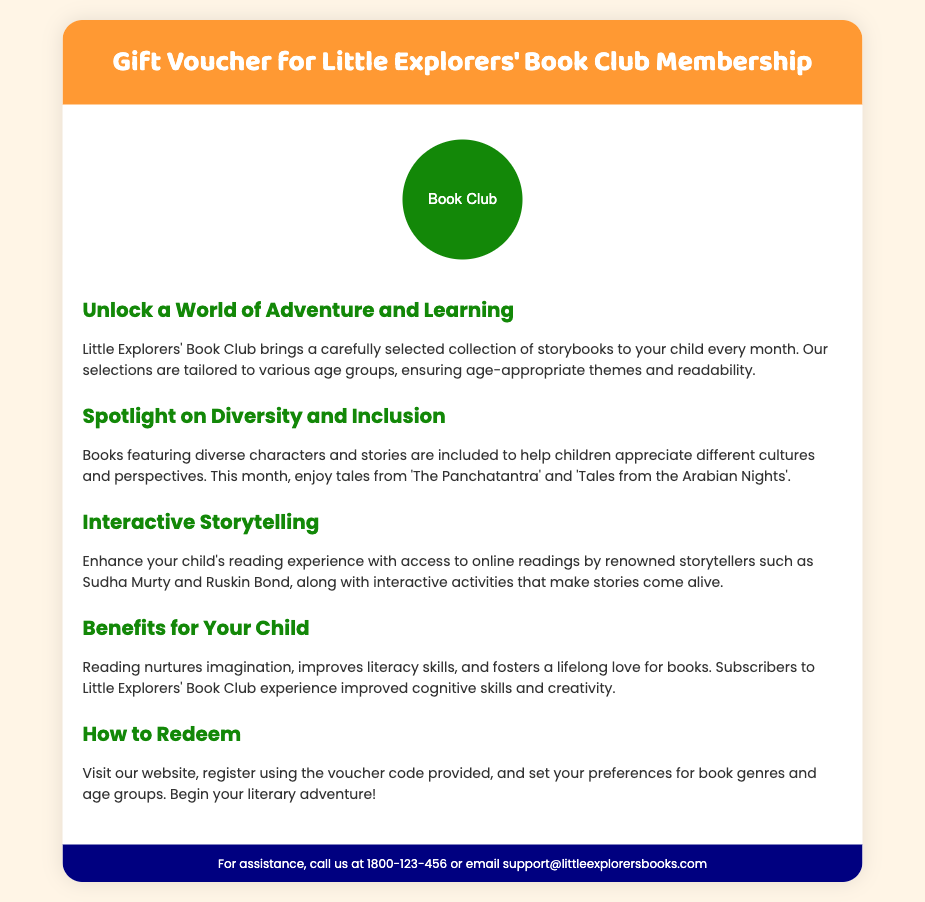What is the name of the book club? The document explicitly mentions the book club's name as "Little Explorers' Book Club."
Answer: Little Explorers' Book Club What is the color of the header? The header section of the voucher is primarily colored in orange, as indicated by the style code provided.
Answer: Orange Who are some of the renowned storytellers mentioned? The document lists Sudha Murty and Ruskin Bond as renowned storytellers featured in the online readings.
Answer: Sudha Murty and Ruskin Bond What type of books are included in the book club? The club offers a collection of "storybooks," which are tailored to various age groups and themes.
Answer: Storybooks How can a voucher be redeemed? The document explains that you need to visit the website, register with the voucher code, and set preferences for genres and age groups.
Answer: Visit the website, register, and set preferences What is the primary benefit of reading mentioned in the document? The document states that reading nurtures imagination and improves literacy skills, highlighting the importance of these aspects.
Answer: Nurtures imagination and improves literacy skills Which months' tales are highlighted in the diversity section? The document specifically mentions "The Panchatantra" and "Tales from the Arabian Nights" in the diversity spotlight.
Answer: The Panchatantra and Tales from the Arabian Nights What is the background color of the footer? The footer is described as having a navy blue background color.
Answer: Navy blue 